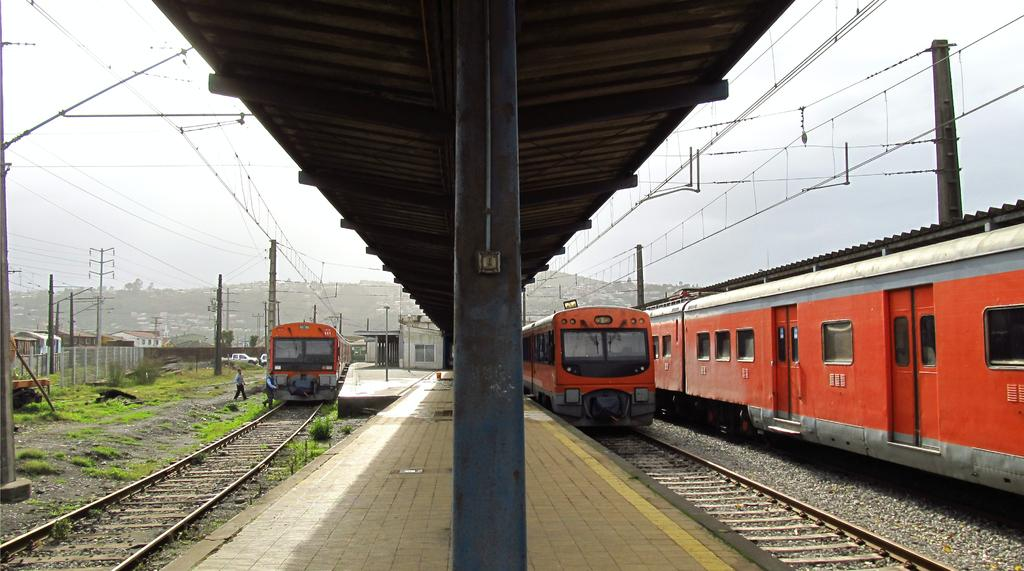What type of transportation can be seen on the railway tracks in the image? There are trains on the railway tracks in the image. What structures are present near the railway tracks? There are current poles and fencing in the image. What type of vegetation is visible in the image? There are trees and grass in the image. What type of buildings can be seen in the image? There are houses in the image. What is the person in the image doing? The person's activity cannot be determined from the image. What type of skirt is the pig wearing in the image? There is no pig or skirt present in the image. How does the person in the image move from one location to another? The person's mode of transportation cannot be determined from the image. 